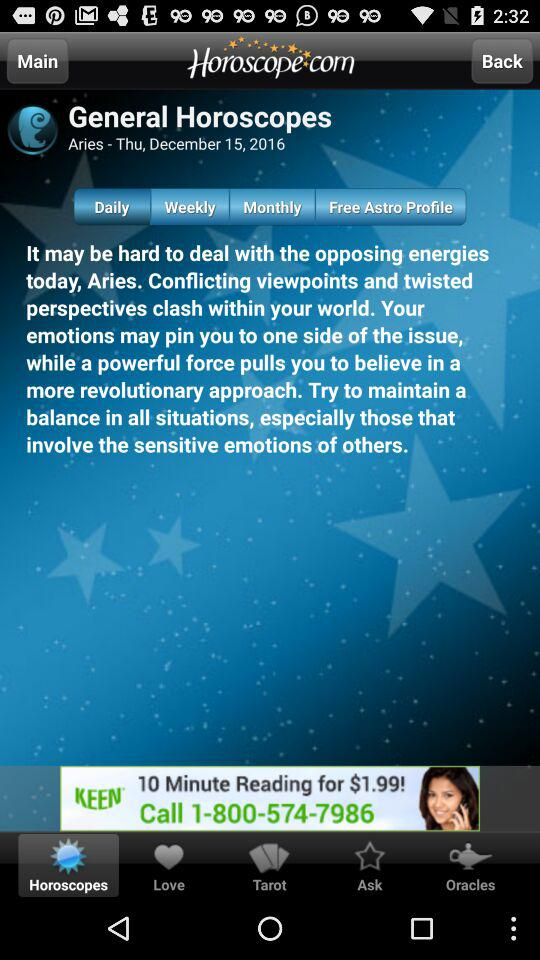What is the website name?
Answer the question using a single word or phrase. The website name is "Horoscope.com" 